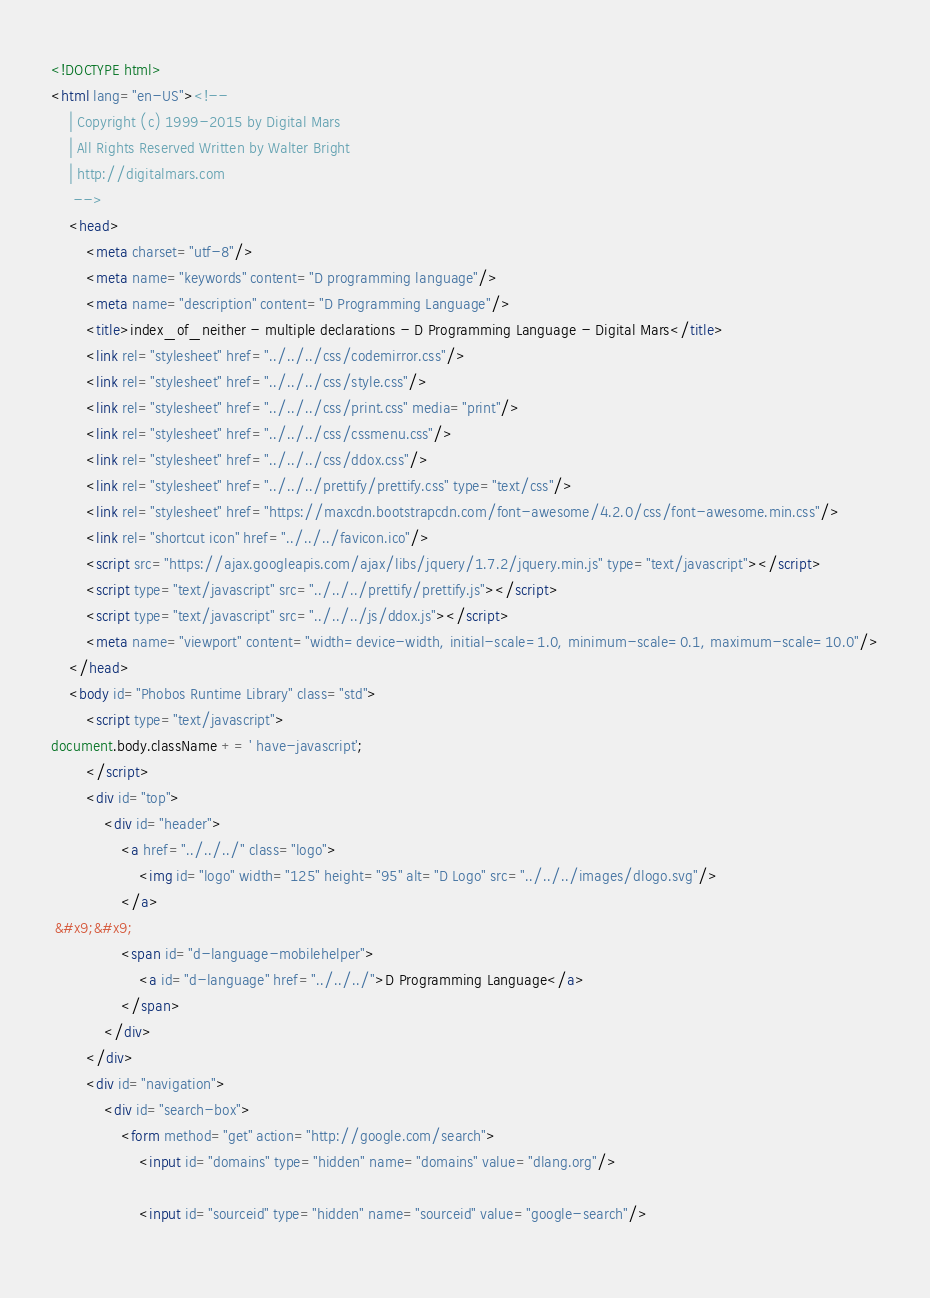<code> <loc_0><loc_0><loc_500><loc_500><_HTML_><!DOCTYPE html>
<html lang="en-US"><!-- 
    | Copyright (c) 1999-2015 by Digital Mars
    | All Rights Reserved Written by Walter Bright
    | http://digitalmars.com
	 -->
	<head>
		<meta charset="utf-8"/>
		<meta name="keywords" content="D programming language"/>
		<meta name="description" content="D Programming Language"/>
		<title>index_of_neither - multiple declarations - D Programming Language - Digital Mars</title>
		<link rel="stylesheet" href="../../../css/codemirror.css"/>
		<link rel="stylesheet" href="../../../css/style.css"/>
		<link rel="stylesheet" href="../../../css/print.css" media="print"/>
		<link rel="stylesheet" href="../../../css/cssmenu.css"/>
		<link rel="stylesheet" href="../../../css/ddox.css"/>
		<link rel="stylesheet" href="../../../prettify/prettify.css" type="text/css"/>
		<link rel="stylesheet" href="https://maxcdn.bootstrapcdn.com/font-awesome/4.2.0/css/font-awesome.min.css"/>
		<link rel="shortcut icon" href="../../../favicon.ico"/>
		<script src="https://ajax.googleapis.com/ajax/libs/jquery/1.7.2/jquery.min.js" type="text/javascript"></script>
		<script type="text/javascript" src="../../../prettify/prettify.js"></script>
		<script type="text/javascript" src="../../../js/ddox.js"></script>
		<meta name="viewport" content="width=device-width, initial-scale=1.0, minimum-scale=0.1, maximum-scale=10.0"/>
	</head>
	<body id="Phobos Runtime Library" class="std">
		<script type="text/javascript">
document.body.className += ' have-javascript';
		</script>
		<div id="top">
			<div id="header">
				<a href="../../../" class="logo">
					<img id="logo" width="125" height="95" alt="D Logo" src="../../../images/dlogo.svg"/>
				</a>
 &#x9;&#x9;
				<span id="d-language-mobilehelper">
					<a id="d-language" href="../../../">D Programming Language</a>
				</span>
			</div>
		</div>
		<div id="navigation">
			<div id="search-box">
				<form method="get" action="http://google.com/search">
					<input id="domains" type="hidden" name="domains" value="dlang.org"/>
             
					<input id="sourceid" type="hidden" name="sourceid" value="google-search"/>
             </code> 